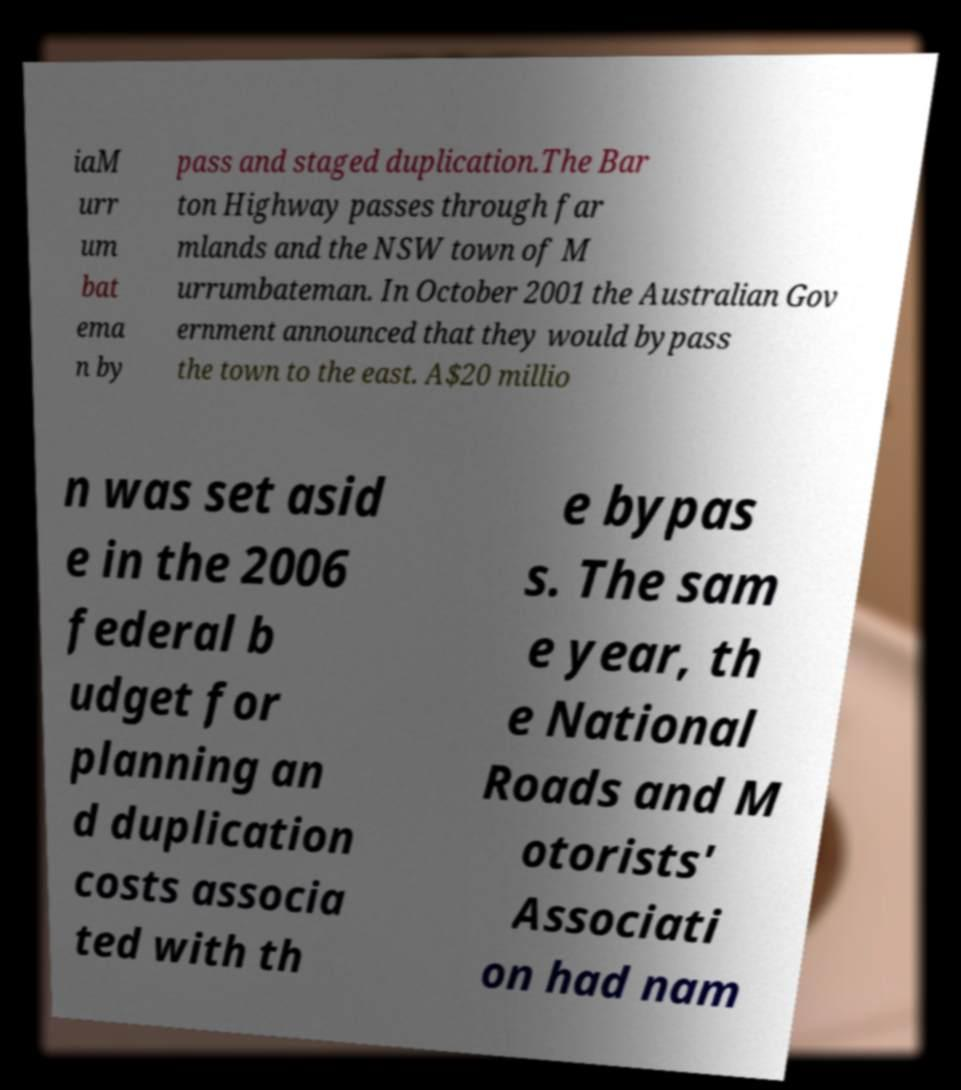I need the written content from this picture converted into text. Can you do that? iaM urr um bat ema n by pass and staged duplication.The Bar ton Highway passes through far mlands and the NSW town of M urrumbateman. In October 2001 the Australian Gov ernment announced that they would bypass the town to the east. A$20 millio n was set asid e in the 2006 federal b udget for planning an d duplication costs associa ted with th e bypas s. The sam e year, th e National Roads and M otorists' Associati on had nam 